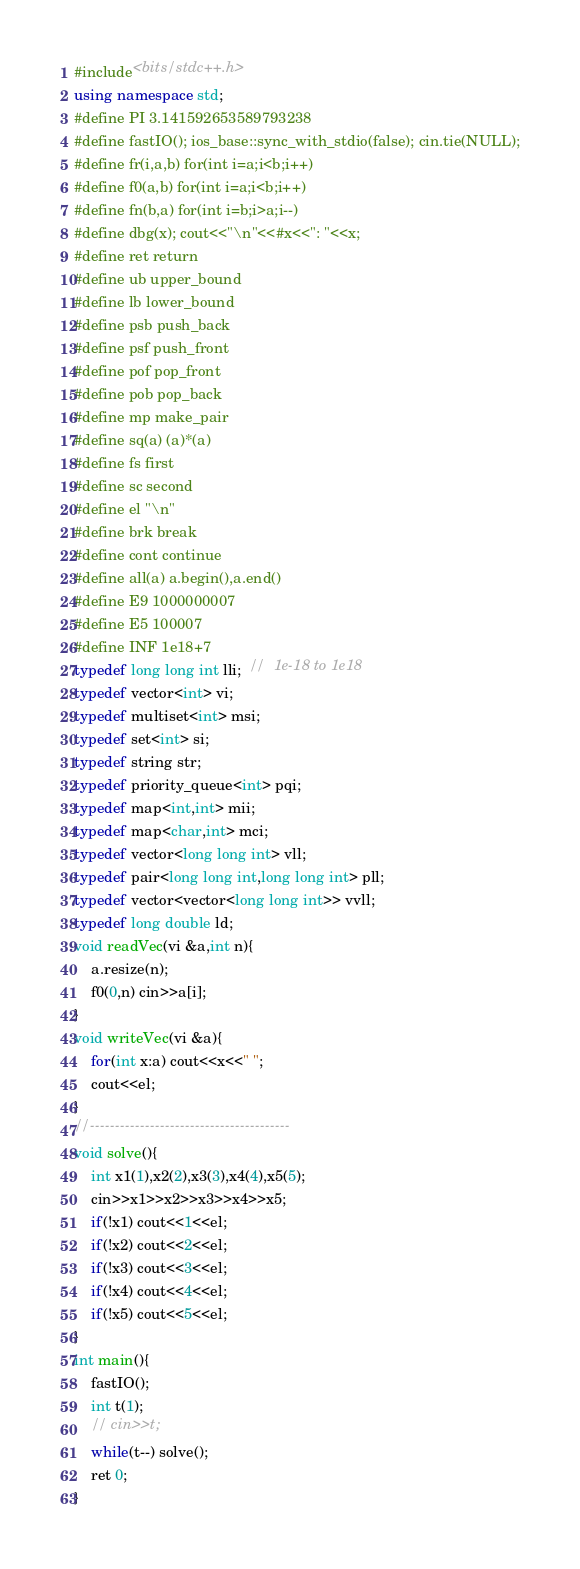<code> <loc_0><loc_0><loc_500><loc_500><_C++_>#include<bits/stdc++.h>
using namespace std;
#define PI 3.141592653589793238
#define fastIO(); ios_base::sync_with_stdio(false); cin.tie(NULL);
#define fr(i,a,b) for(int i=a;i<b;i++)
#define f0(a,b) for(int i=a;i<b;i++)
#define fn(b,a) for(int i=b;i>a;i--)
#define dbg(x); cout<<"\n"<<#x<<": "<<x;
#define ret return
#define ub upper_bound
#define lb lower_bound
#define psb push_back
#define psf push_front
#define pof pop_front
#define pob pop_back
#define mp make_pair
#define sq(a) (a)*(a)
#define fs first
#define sc second
#define el "\n"
#define brk break
#define cont continue
#define all(a) a.begin(),a.end()
#define E9 1000000007
#define E5 100007
#define INF 1e18+7
typedef long long int lli;  //  1e-18 to 1e18
typedef vector<int> vi;
typedef multiset<int> msi;
typedef set<int> si;
typedef string str;
typedef priority_queue<int> pqi;
typedef map<int,int> mii;
typedef map<char,int> mci;
typedef vector<long long int> vll;
typedef pair<long long int,long long int> pll;
typedef vector<vector<long long int>> vvll;
typedef long double ld;
void readVec(vi &a,int n){
    a.resize(n);
    f0(0,n) cin>>a[i];
}
void writeVec(vi &a){
	for(int x:a) cout<<x<<" ";
	cout<<el;
}
//----------------------------------------
void solve(){
    int x1(1),x2(2),x3(3),x4(4),x5(5);
    cin>>x1>>x2>>x3>>x4>>x5;
    if(!x1) cout<<1<<el;
    if(!x2) cout<<2<<el;
    if(!x3) cout<<3<<el;
    if(!x4) cout<<4<<el;
    if(!x5) cout<<5<<el;
}
int main(){
    fastIO();
    int t(1);
    // cin>>t;
    while(t--) solve();
    ret 0; 
}</code> 